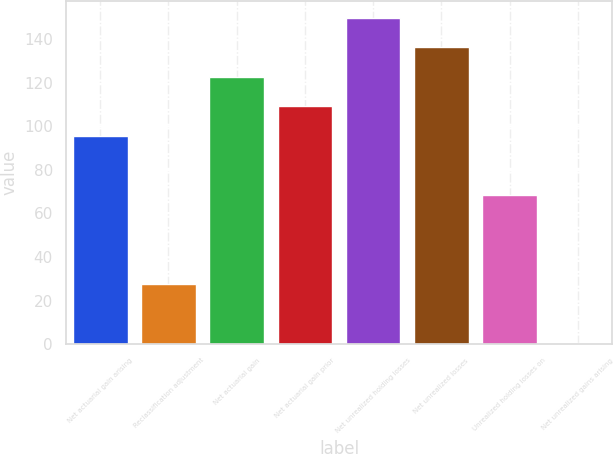<chart> <loc_0><loc_0><loc_500><loc_500><bar_chart><fcel>Net actuarial gain arising<fcel>Reclassification adjustment<fcel>Net actuarial gain<fcel>Net actuarial gain prior<fcel>Net unrealized holding losses<fcel>Net unrealized losses<fcel>Unrealized holding losses on<fcel>Net unrealized gains arising<nl><fcel>95.56<fcel>27.66<fcel>122.72<fcel>109.14<fcel>149.88<fcel>136.3<fcel>68.4<fcel>0.5<nl></chart> 